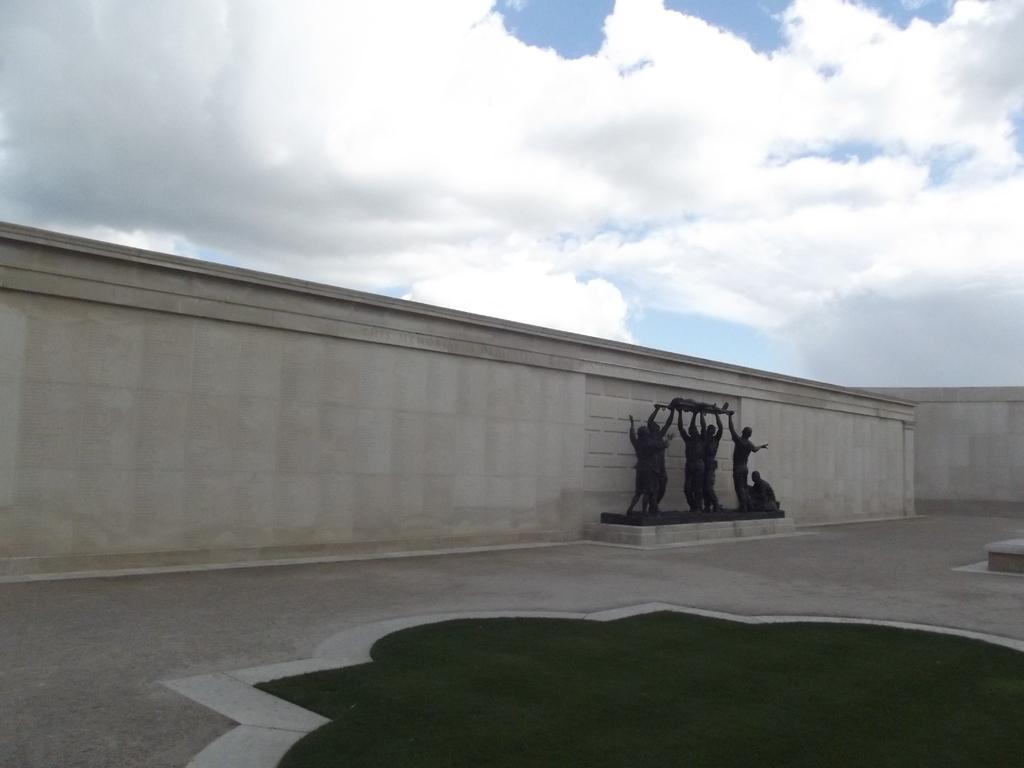What can be seen beside the wall in the image? There are statues beside the wall in the image. What type of vegetation is present on the ground in the image? There is grass on the ground in the image. What is visible in the sky in the image? The sky is visible and appears cloudy in the image. What type of pencil can be seen in the image? There is no pencil present in the image. What did the statues have for breakfast in the image? There is no indication of the statues having breakfast or any other meal in the image. 